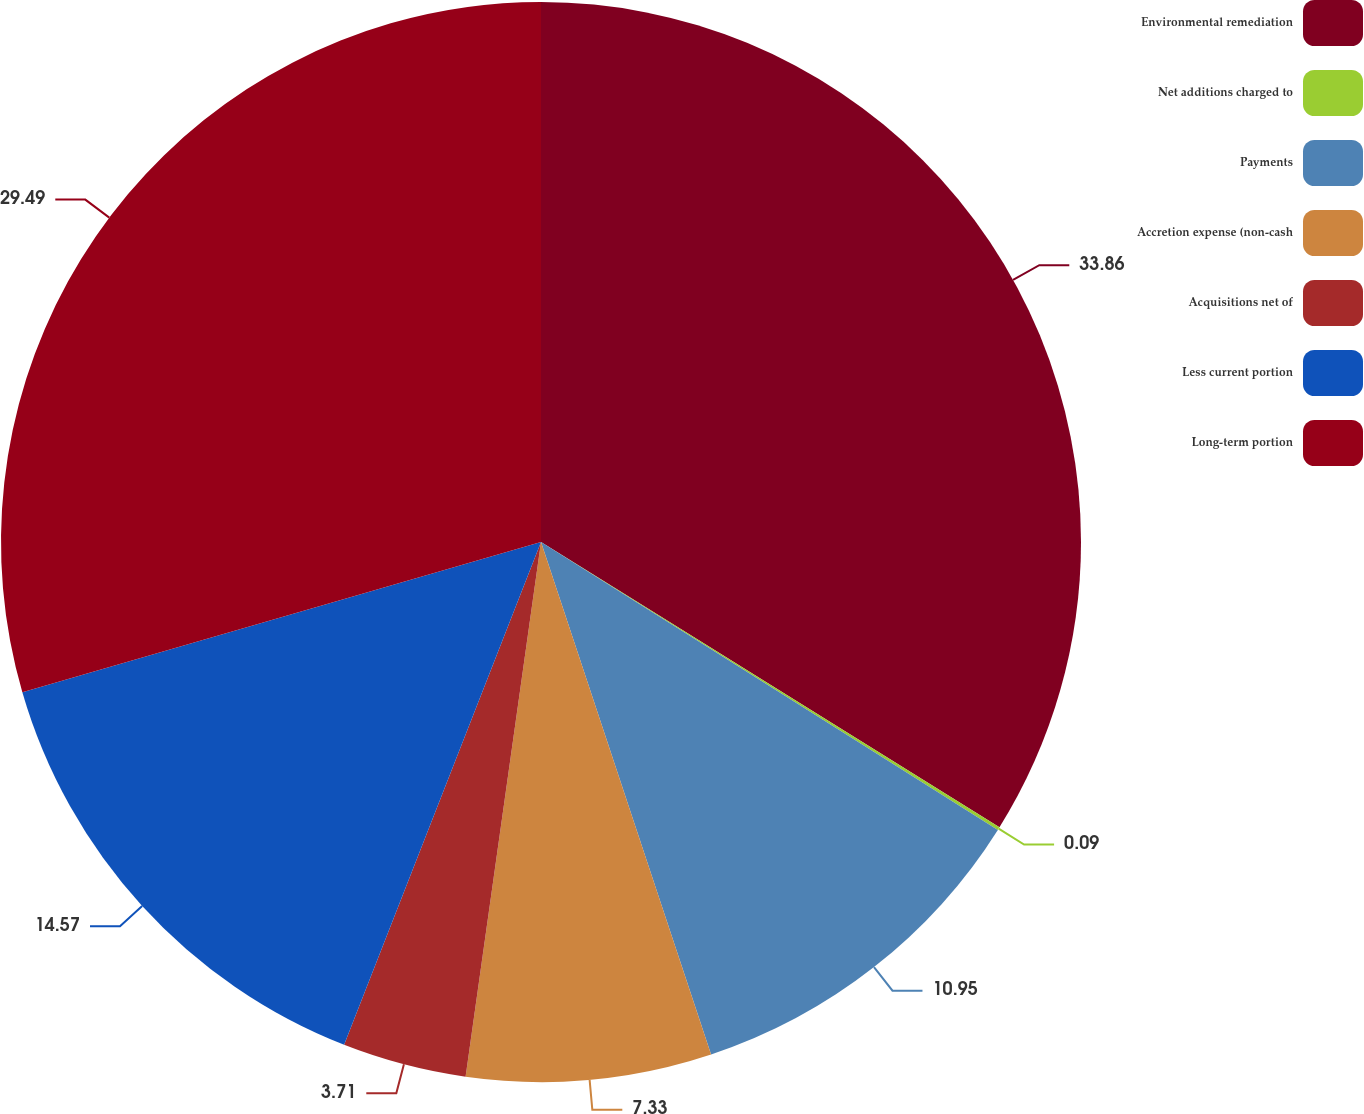<chart> <loc_0><loc_0><loc_500><loc_500><pie_chart><fcel>Environmental remediation<fcel>Net additions charged to<fcel>Payments<fcel>Accretion expense (non-cash<fcel>Acquisitions net of<fcel>Less current portion<fcel>Long-term portion<nl><fcel>33.86%<fcel>0.09%<fcel>10.95%<fcel>7.33%<fcel>3.71%<fcel>14.57%<fcel>29.49%<nl></chart> 